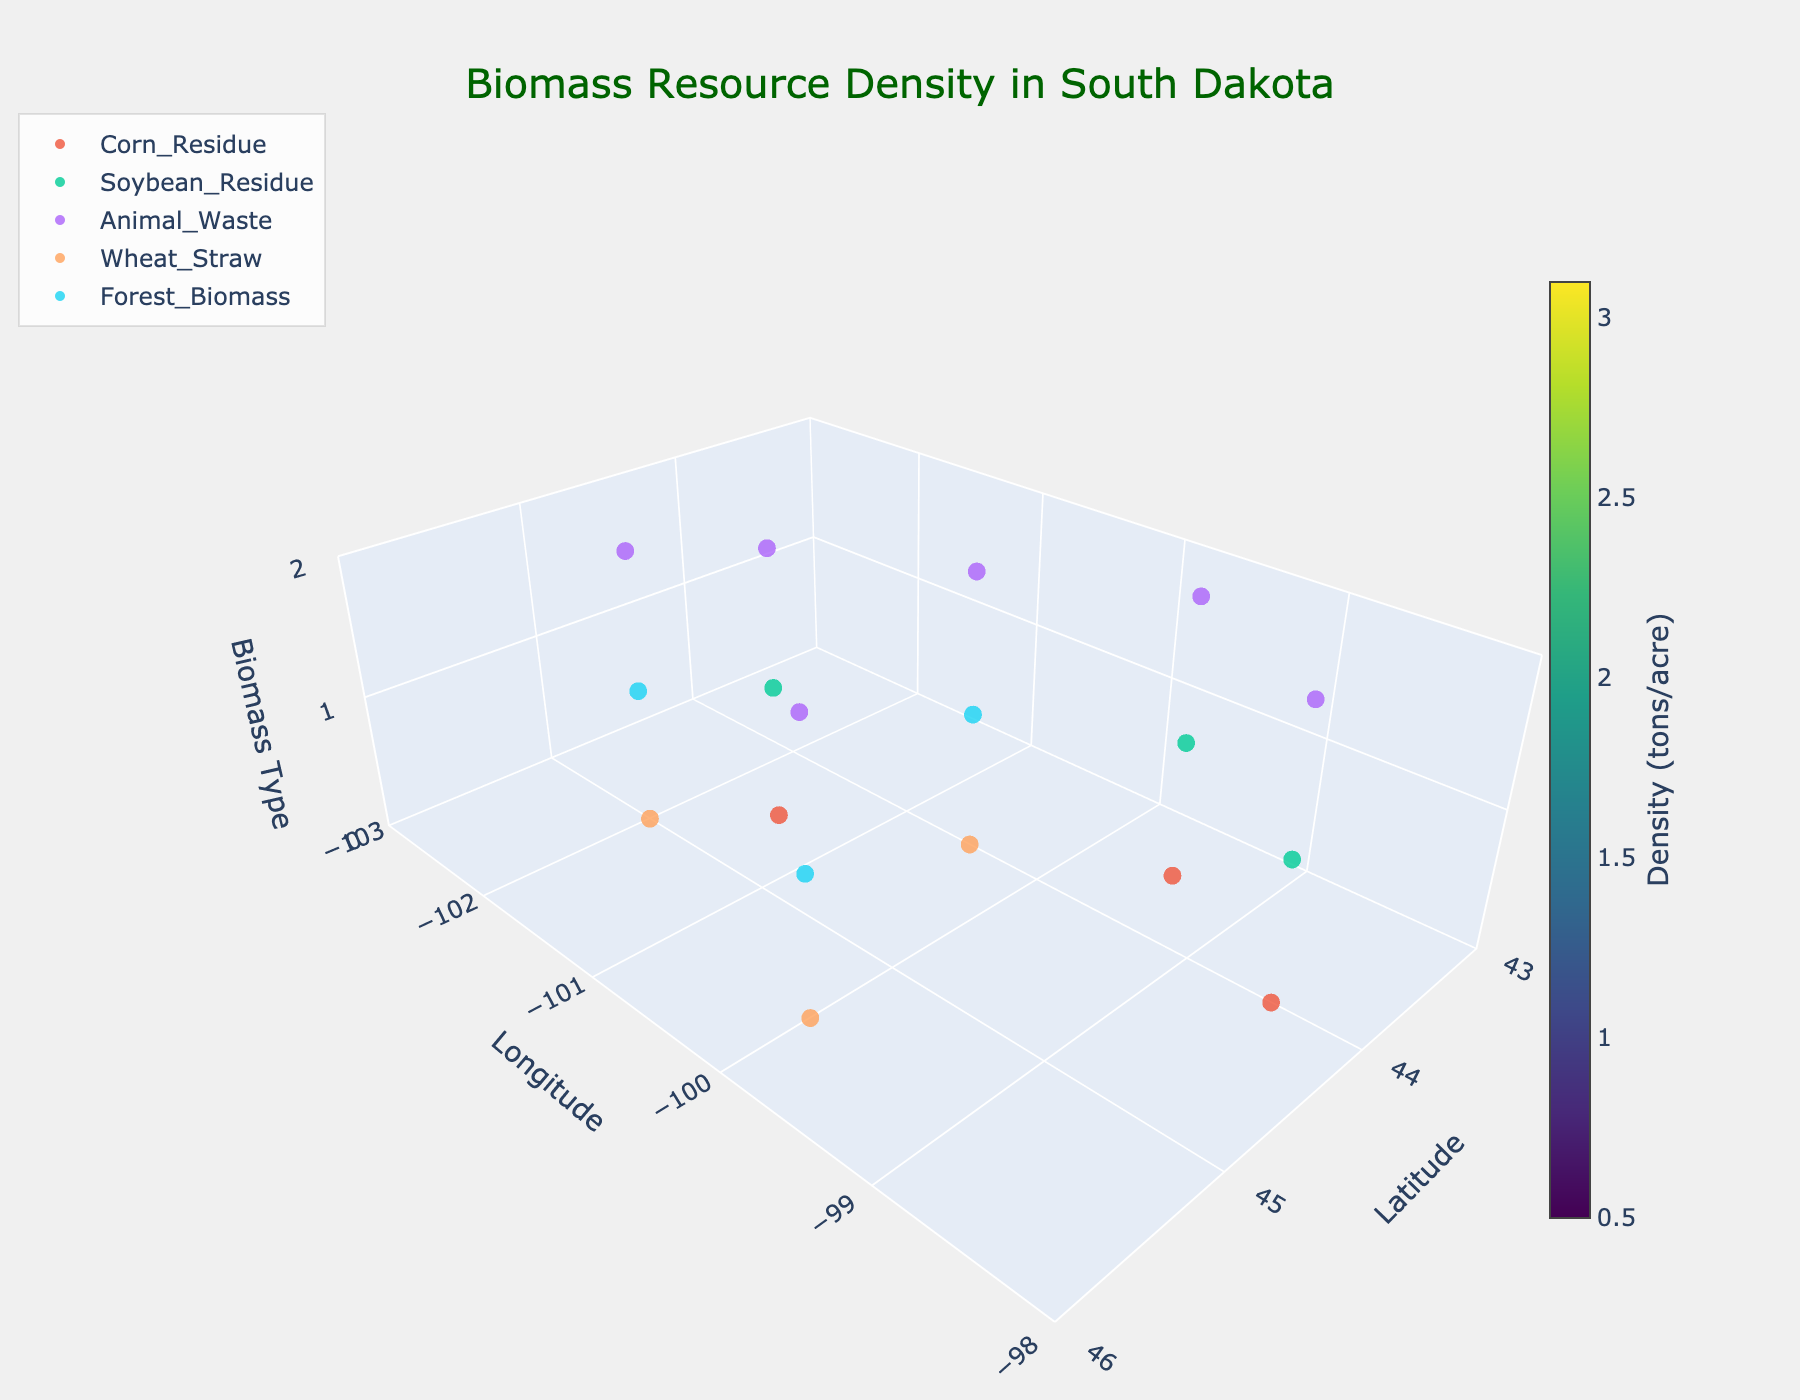What's the title of the plot? The title is usually located at the top of the plot. By looking at the top center text, you can identify it. The title reads 'Biomass Resource Density in South Dakota'.
Answer: Biomass Resource Density in South Dakota What do the x, y, and z axes represent? The axes are labeled, typically at their ends. The x-axis is labeled 'Latitude,' the y-axis is labeled 'Longitude,' and the z-axis is labeled 'Biomass Type.'
Answer: Latitude, Longitude, Biomass Type Which biomass type has the highest density at latitude 43.5 and longitude -99.5? Find the coordinates (43.5, -99.5) on the x and y axes. Check the z-axis position for each biomass type at these coordinates and compare their densities. Corn Residue has the highest density with 3.1 tons/acre.
Answer: Corn Residue How many different biomass types are represented? Inspect the legend or the markers on the plot. The legend shows distinct types listed: Corn Residue, Soybean Residue, Animal Waste, Wheat Straw, and Forest Biomass.
Answer: 5 Which biomass type generally has the lowest density across locations? By examining different points for each biomass type, Forest Biomass tends to have the lowest density values.
Answer: Forest Biomass What is the average density for Animal Waste across all locations? List the densities for Animal Waste: 0.9, 1.1, 1.3, 0.8, 1.0, 0.7. Sum them up: 0.9 + 1.1 + 1.3 + 0.8 + 1.0 + 0.7 = 5.8. Divide by the number of points: 5.8 / 6 = 0.97 tons/acre.
Answer: 0.97 tons/acre Which location has the highest overall total biomass density? Sum the densities for each location: 
- (44.5,-101.5) -> 2.8 + 1.2 + 0.9 = 4.9
- (44.0,-100.5) -> 1.5 + 0.7 + 1.1 = 3.3
- (43.5,-99.5) -> 3.1 + 1.4 + 1.3 = 5.8
- (45.0,-102.0) -> 1.8 + 0.5 + 0.8 = 3.1
- (44.0,-98.5) -> 2.6 + 1.1 + 1.0 = 4.7
- (45.5,-100.0) -> 1.3 + 0.9 + 0.7 = 2.9. The maximum sum is at (43.5, -99.5) with 5.8 tons/acre.
Answer: (43.5, -99.5) Which location has the highest observed density for Corn Residue? Check the densities for Corn Residue: 
- 44.5, -101.5 -> 2.8
- 43.5, -99.5 -> 3.1
- 44.0, -98.5 -> 2.6. The highest density is at 43.5, -99.5 with 3.1 tons/acre.
Answer: 43.5, -99.5 